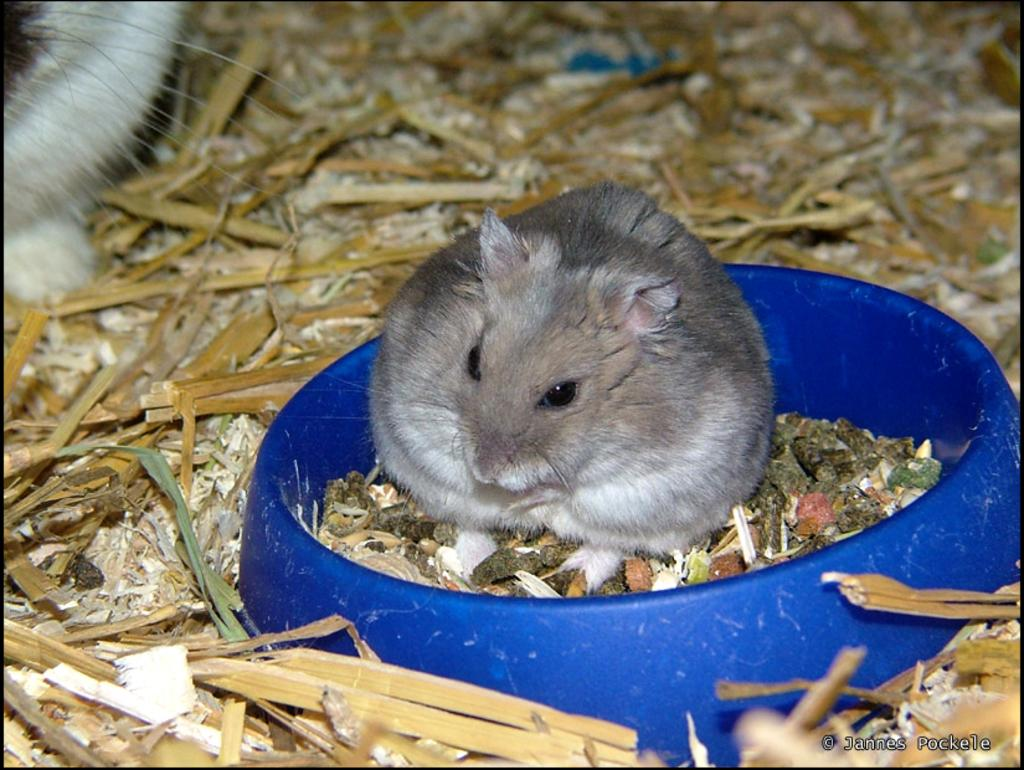What is in the bowl in the image? There is a mouse in a bowl in the image. What else is in the bowl with the mouse? There is some material in the bowl with the mouse. What can be seen at the bottom of the image? There is some material at the bottom of the image. Where is the text located in the image? The text is in the bottom right corner of the image. What type of sofa is depicted in the image? There is no sofa present in the image. What kind of humor can be found in the image? The image does not contain any humor; it simply shows a mouse in a bowl with some material. 